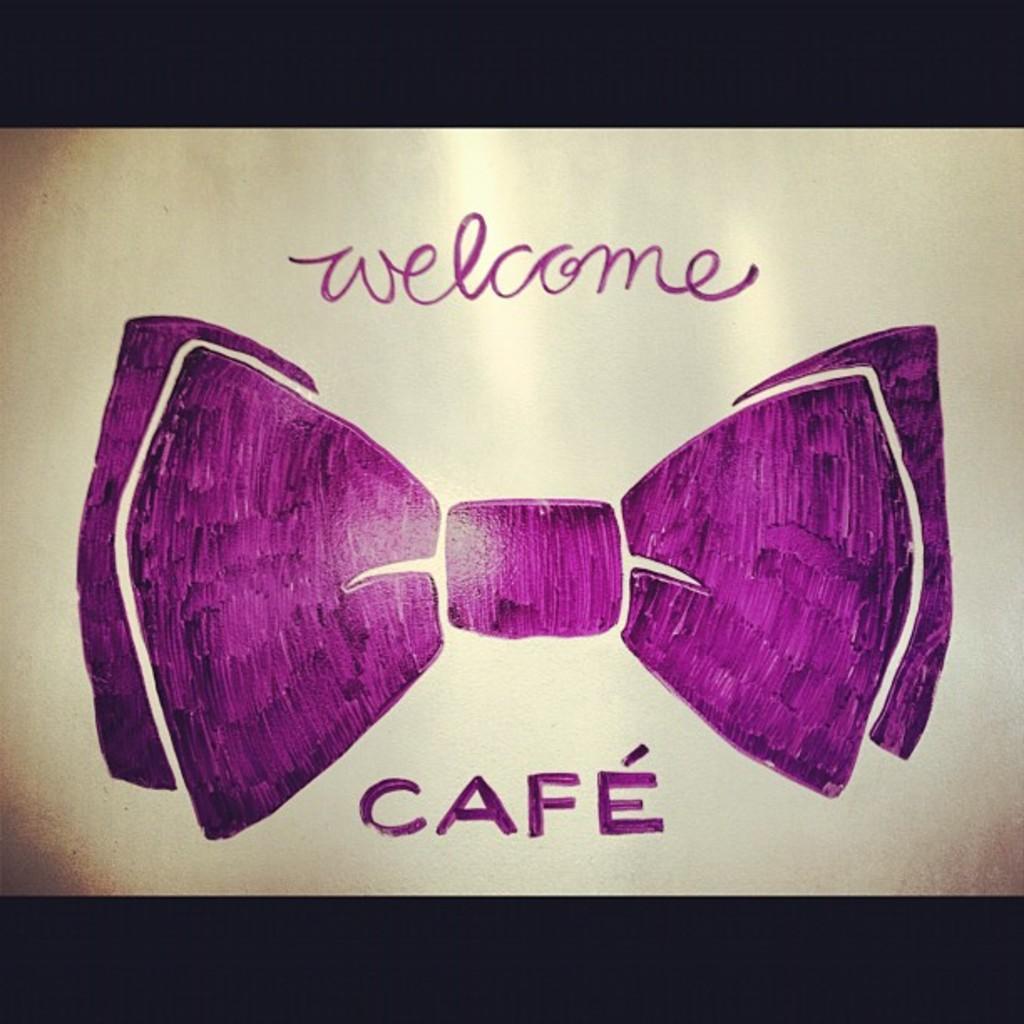Describe this image in one or two sentences. In this image we can see the drawing of a bow tie. We can also see some written text. 